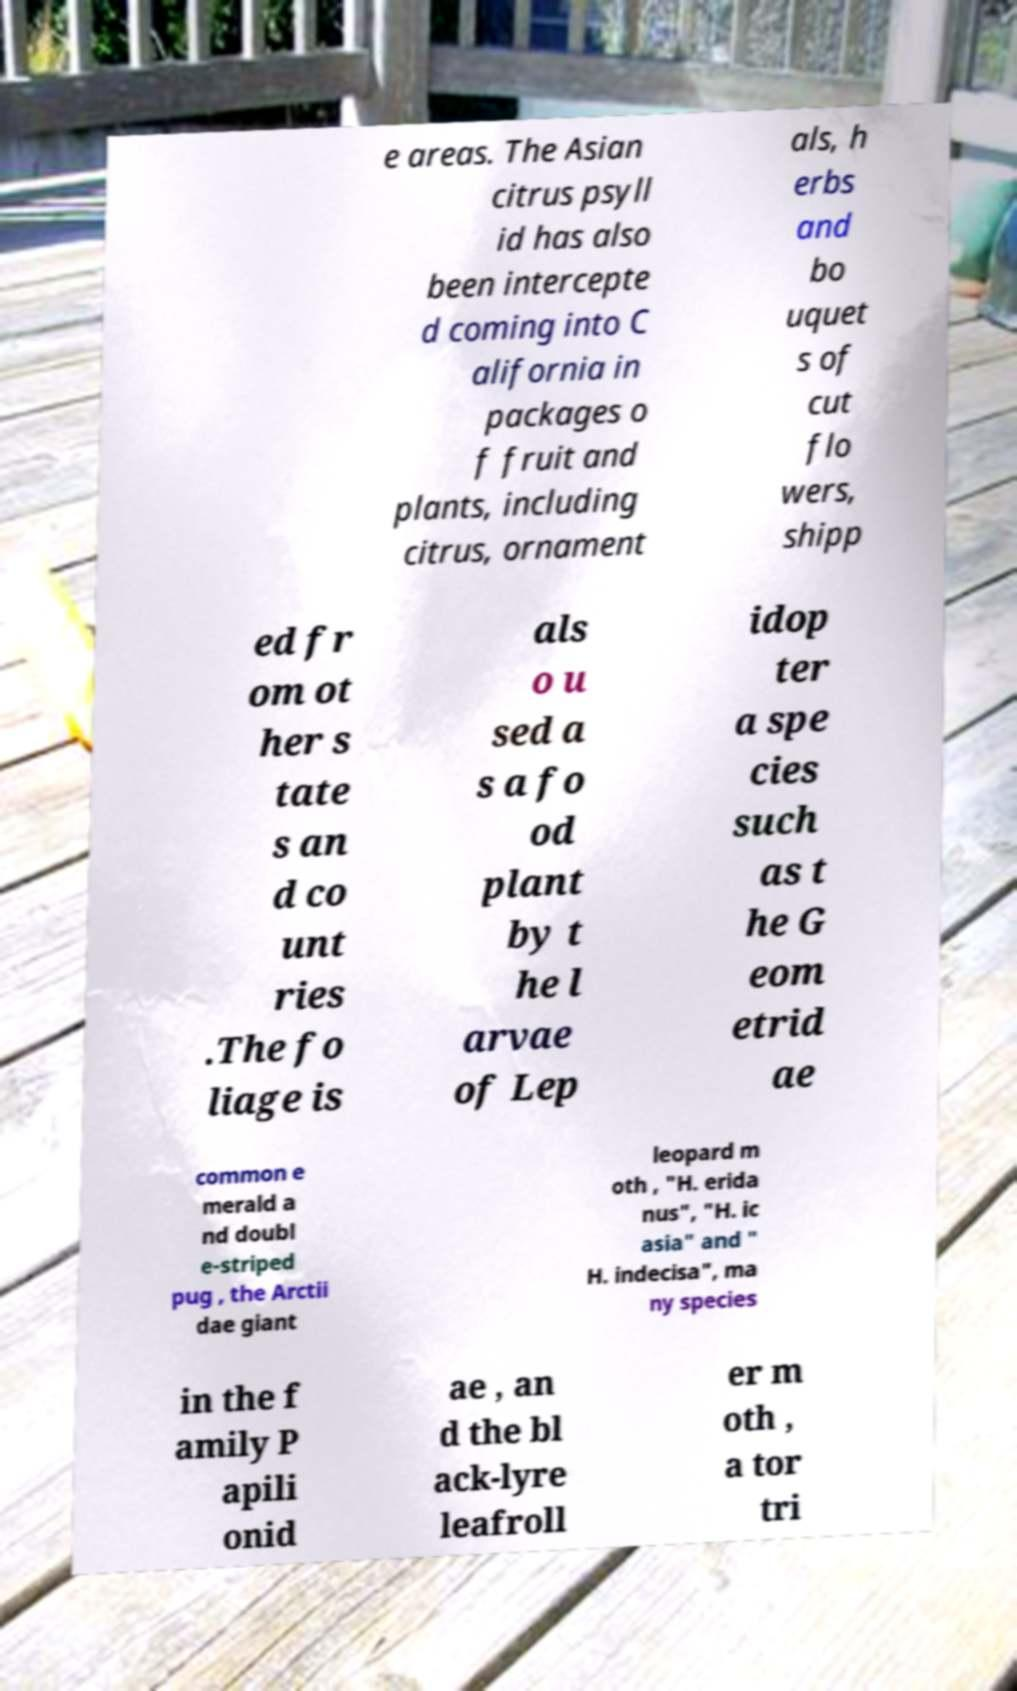For documentation purposes, I need the text within this image transcribed. Could you provide that? e areas. The Asian citrus psyll id has also been intercepte d coming into C alifornia in packages o f fruit and plants, including citrus, ornament als, h erbs and bo uquet s of cut flo wers, shipp ed fr om ot her s tate s an d co unt ries .The fo liage is als o u sed a s a fo od plant by t he l arvae of Lep idop ter a spe cies such as t he G eom etrid ae common e merald a nd doubl e-striped pug , the Arctii dae giant leopard m oth , "H. erida nus", "H. ic asia" and " H. indecisa", ma ny species in the f amily P apili onid ae , an d the bl ack-lyre leafroll er m oth , a tor tri 